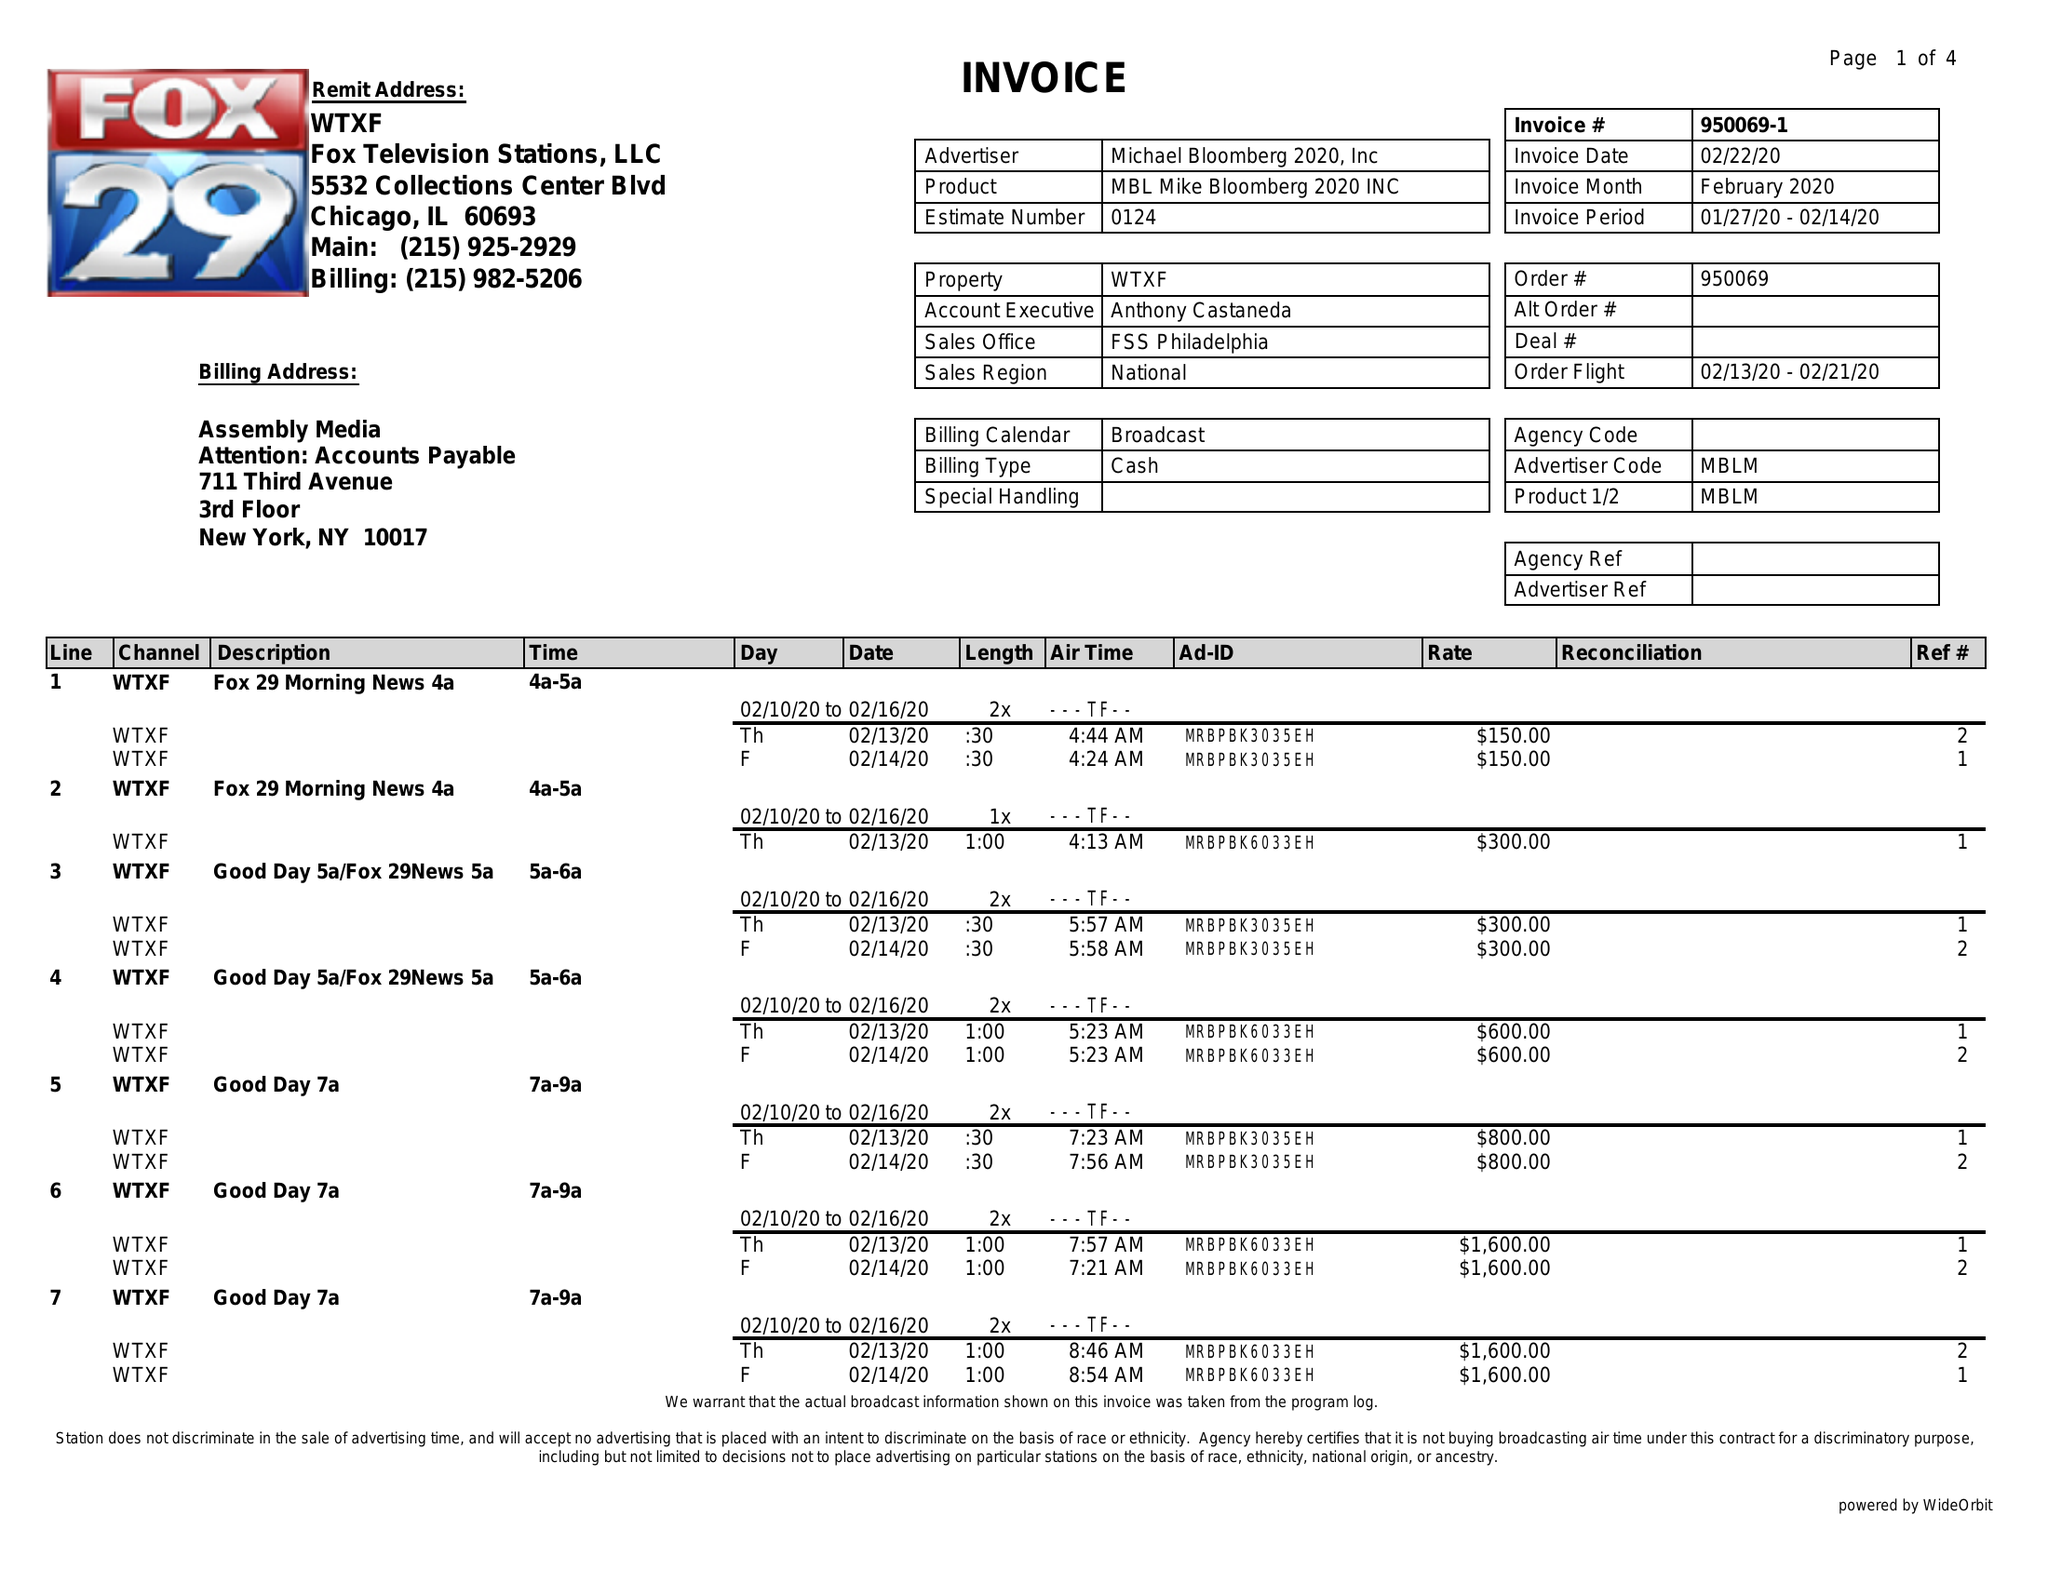What is the value for the contract_num?
Answer the question using a single word or phrase. 950069 